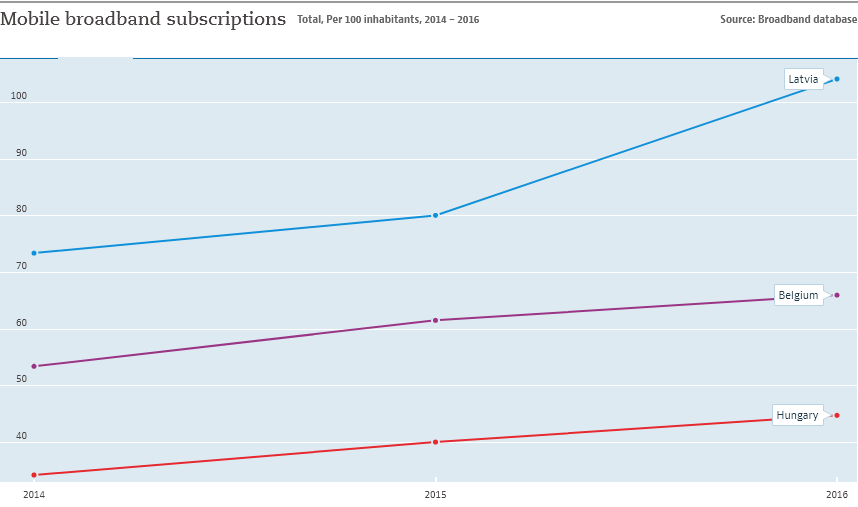Specify some key components in this picture. In 2016, the highest number of broadband subscriptions was recorded in Belgium. The country represented by the blue color line is Latvia. 